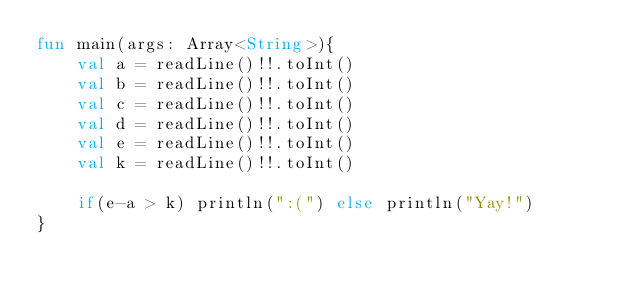<code> <loc_0><loc_0><loc_500><loc_500><_Kotlin_>fun main(args: Array<String>){
    val a = readLine()!!.toInt()
    val b = readLine()!!.toInt()
    val c = readLine()!!.toInt()
    val d = readLine()!!.toInt()
    val e = readLine()!!.toInt()
    val k = readLine()!!.toInt()
    
    if(e-a > k) println(":(") else println("Yay!")
}</code> 